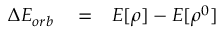Convert formula to latex. <formula><loc_0><loc_0><loc_500><loc_500>\begin{array} { r l r } { \Delta E _ { o r b } } & = } & { E [ \rho ] - E [ \rho ^ { 0 } ] } \end{array}</formula> 